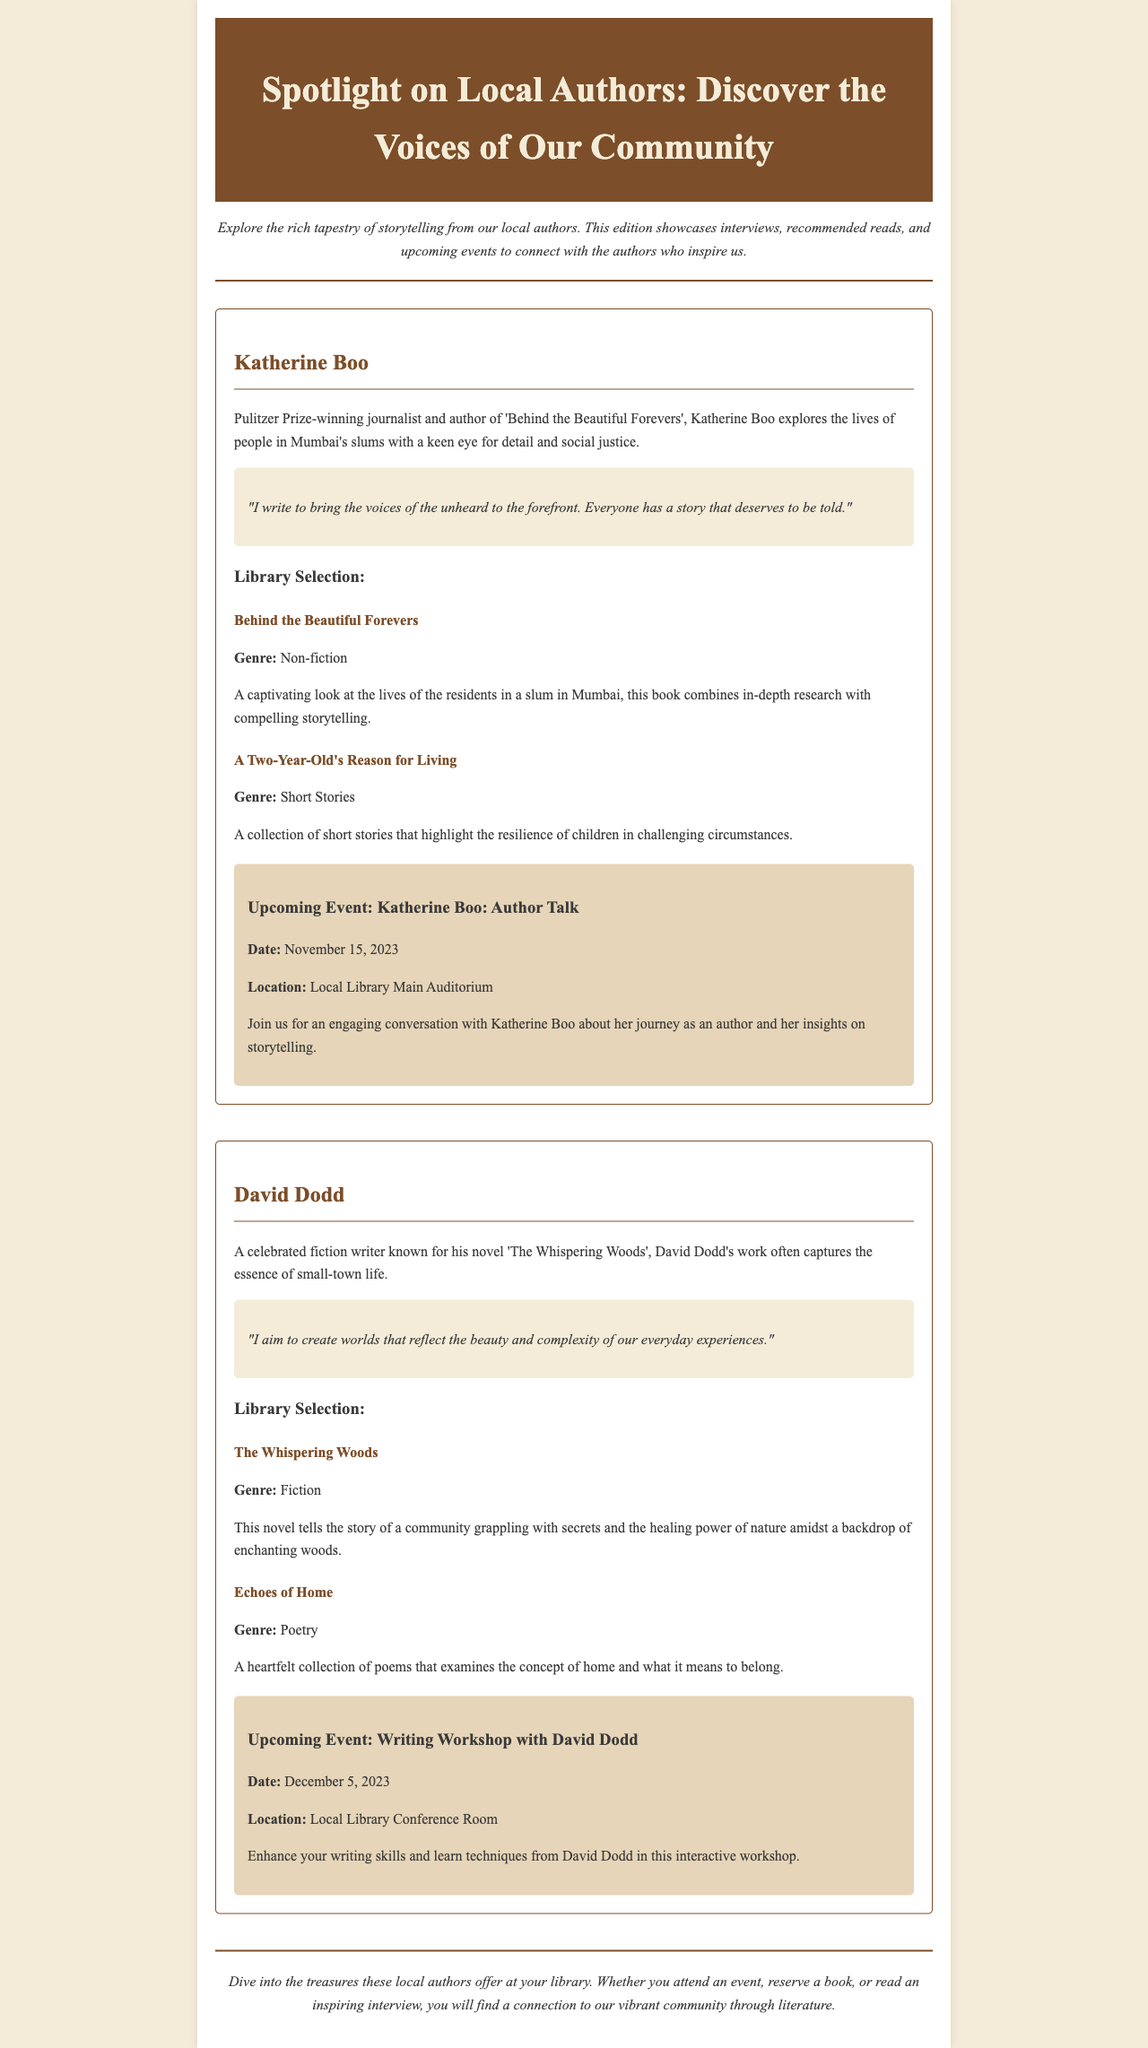What is the title of the newsletter? The title is prominently displayed in the header of the document.
Answer: Spotlight on Local Authors: Discover the Voices of Our Community Who is a Pulitzer Prize-winning author featured in the newsletter? The newsletter specifically mentions Katherine Boo as a Pulitzer Prize-winning journalist and author.
Answer: Katherine Boo What is the genre of "Behind the Beautiful Forevers"? The genre is listed under the book details provided for Katherine Boo's work.
Answer: Non-fiction When is the upcoming event with David Dodd? The date of the event is stated clearly in the event section for David Dodd.
Answer: December 5, 2023 What type of workshop is David Dodd conducting? The newsletter describes the nature of the upcoming event with David Dodd.
Answer: Writing Workshop What is the main theme of Katherine Boo's interview quote? The quote reflects Katherine Boo's motivation and purpose for writing.
Answer: Voices of the unheard What does David Dodd aim to create in his writing? David Dodd's quote reveals his intent regarding the worlds he builds through his work.
Answer: Worlds that reflect beauty and complexity Which book highlights the resilience of children? The answer is found in the library selection section under Katherine Boo's works.
Answer: A Two-Year-Old's Reason for Living 